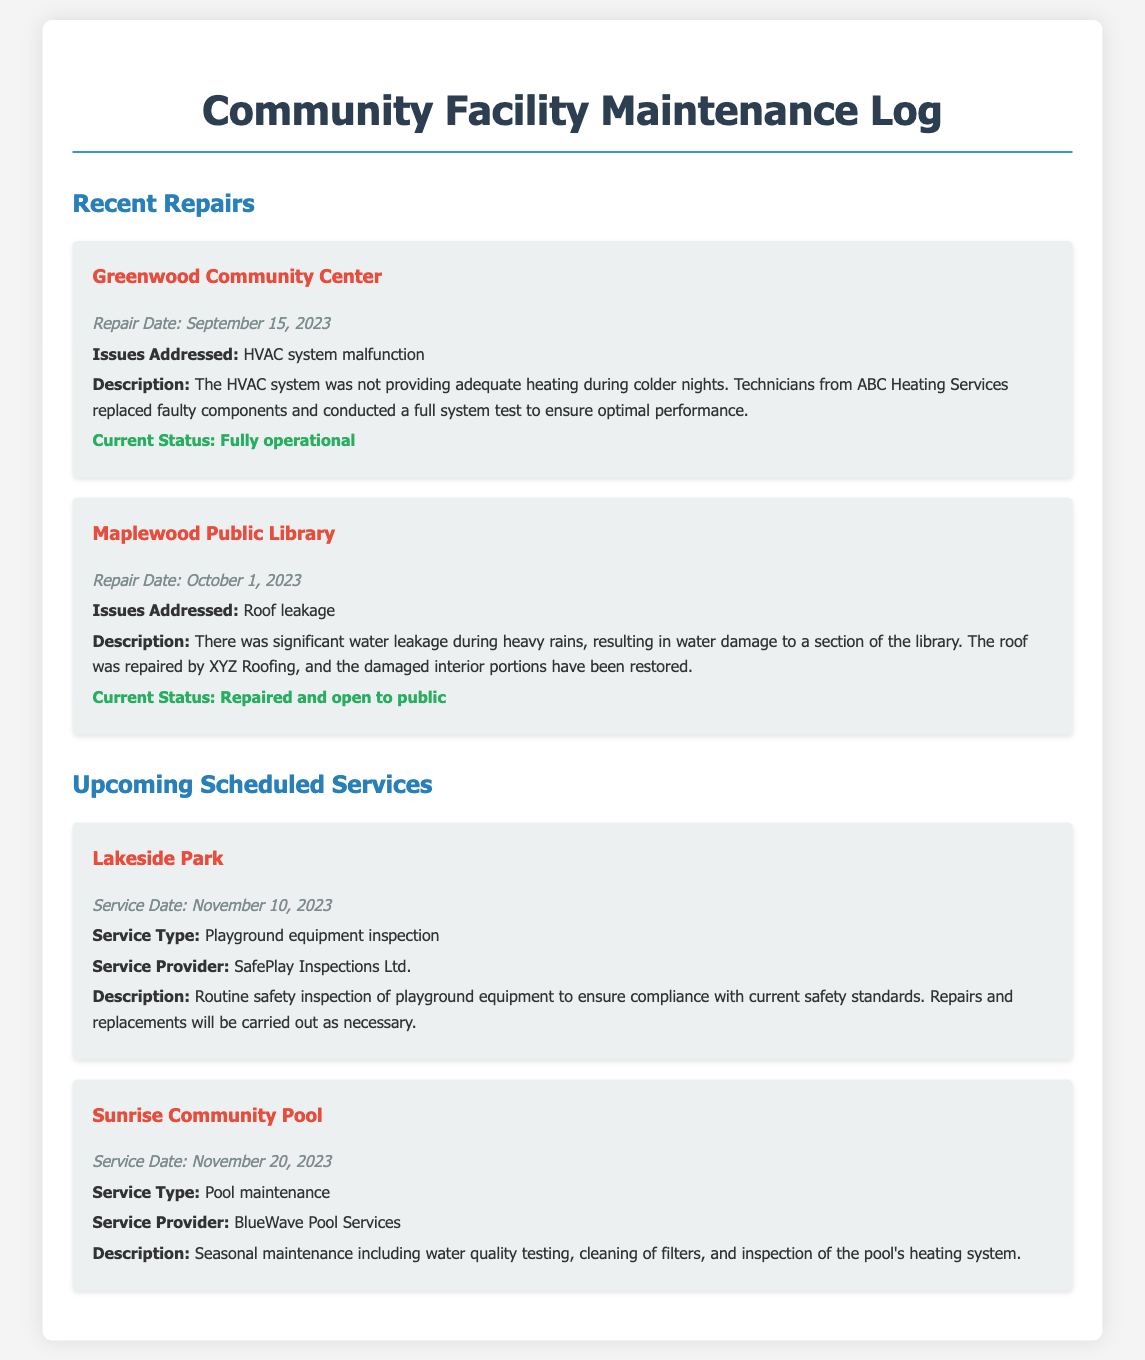What is the repair date for Greenwood Community Center? The repair date is stated clearly under the "Recent Repairs" section for Greenwood Community Center as September 15, 2023.
Answer: September 15, 2023 What issue was addressed at Maplewood Public Library? Each facility lists specific issues addressed; for Maplewood Public Library, it was roof leakage.
Answer: Roof leakage What is the service date for Lakeside Park? The document specifies the upcoming scheduled service date for Lakeside Park under "Upcoming Scheduled Services" as November 10, 2023.
Answer: November 10, 2023 Who conducted the recent repairs at the Greenwood Community Center? The document mentions that technicians from ABC Heating Services handled the repairs for the Greenwood Community Center.
Answer: ABC Heating Services What type of service is scheduled for Sunrise Community Pool? The document details that the scheduled service type for Sunrise Community Pool is pool maintenance.
Answer: Pool maintenance What was the status of the Maplewood Public Library after repairs? The document indicates the current status of the library as repaired and open to public.
Answer: Repaired and open to public How often is the playground equipment inspected at Lakeside Park? While the document lists a specific upcoming service date, it is implied that inspections are routine, which could be interpreted as at least annually, aligning with safety standards.
Answer: Routine What repairs will be carried out if necessary at Lakeside Park? The document states that repairs and replacements will be carried out as necessary following the playground equipment inspection.
Answer: Repairs and replacements What is included in the seasonal maintenance at Sunrise Community Pool? The document indicates that the maintenance will include water quality testing, cleaning of filters, and inspection of the pool's heating system.
Answer: Water quality testing, cleaning of filters, and inspection of heating system 